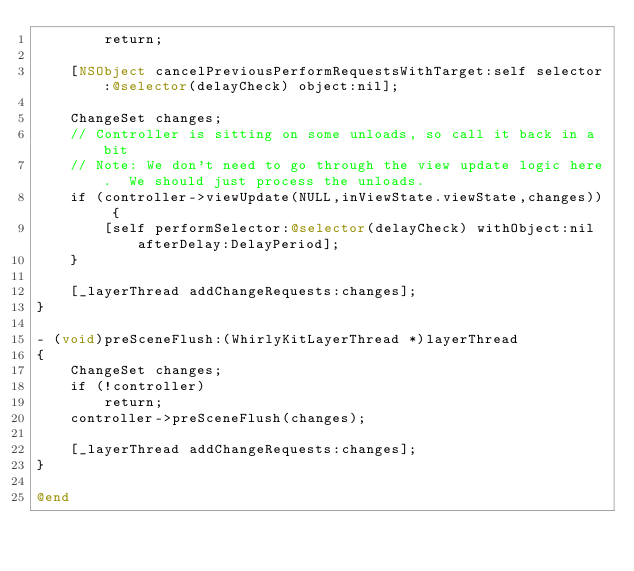Convert code to text. <code><loc_0><loc_0><loc_500><loc_500><_ObjectiveC_>        return;
    
    [NSObject cancelPreviousPerformRequestsWithTarget:self selector:@selector(delayCheck) object:nil];

    ChangeSet changes;
    // Controller is sitting on some unloads, so call it back in a bit
    // Note: We don't need to go through the view update logic here.  We should just process the unloads.
    if (controller->viewUpdate(NULL,inViewState.viewState,changes)) {
        [self performSelector:@selector(delayCheck) withObject:nil afterDelay:DelayPeriod];
    }
    
    [_layerThread addChangeRequests:changes];
}

- (void)preSceneFlush:(WhirlyKitLayerThread *)layerThread
{
    ChangeSet changes;
    if (!controller)
        return;
    controller->preSceneFlush(changes);
    
    [_layerThread addChangeRequests:changes];
}

@end
</code> 